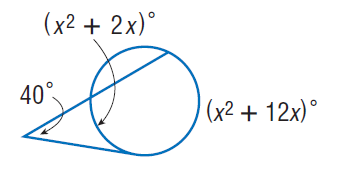Question: Find x. Assume that any segment that appears to be tangent is tangent.
Choices:
A. 8
B. 40
C. 80
D. 160
Answer with the letter. Answer: A 